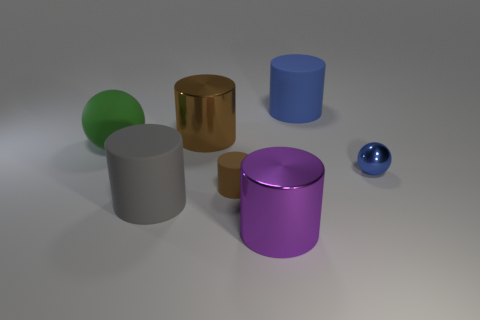Add 3 big shiny things. How many objects exist? 10 Subtract all gray balls. How many brown cylinders are left? 2 Subtract all blue cylinders. How many cylinders are left? 4 Subtract all big gray rubber cylinders. How many cylinders are left? 4 Subtract 1 cylinders. How many cylinders are left? 4 Subtract all red cylinders. Subtract all cyan spheres. How many cylinders are left? 5 Subtract all spheres. How many objects are left? 5 Subtract 0 purple cubes. How many objects are left? 7 Subtract all big objects. Subtract all big matte spheres. How many objects are left? 1 Add 3 large blue objects. How many large blue objects are left? 4 